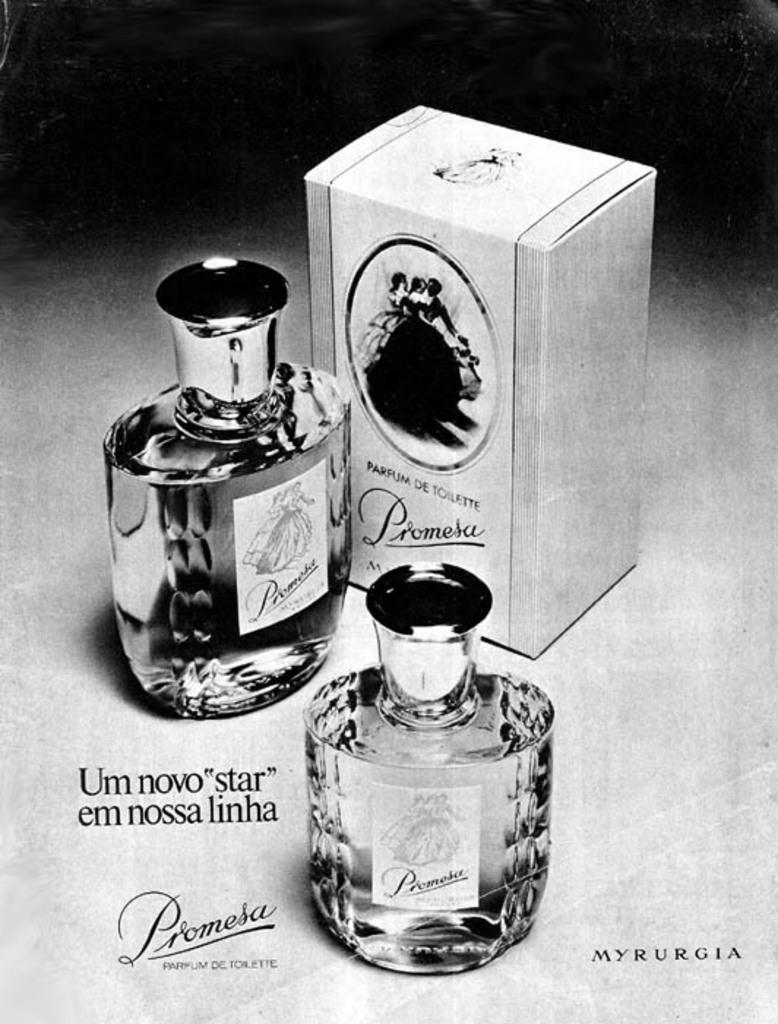<image>
Create a compact narrative representing the image presented. the word Promesa is next to a couple perfume bottles 